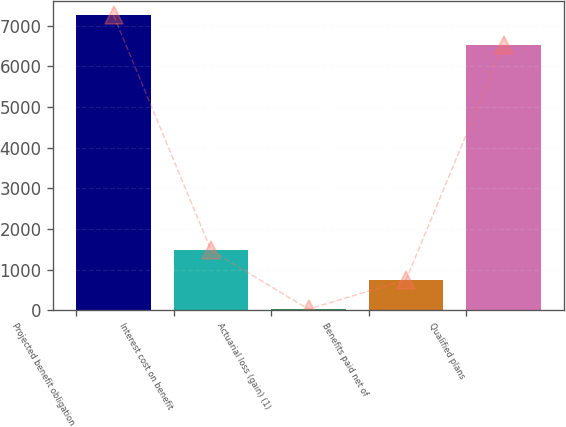Convert chart to OTSL. <chart><loc_0><loc_0><loc_500><loc_500><bar_chart><fcel>Projected benefit obligation<fcel>Interest cost on benefit<fcel>Actuarial loss (gain) (1)<fcel>Benefits paid net of<fcel>Qualified plans<nl><fcel>7256.4<fcel>1472.8<fcel>28<fcel>750.4<fcel>6534<nl></chart> 